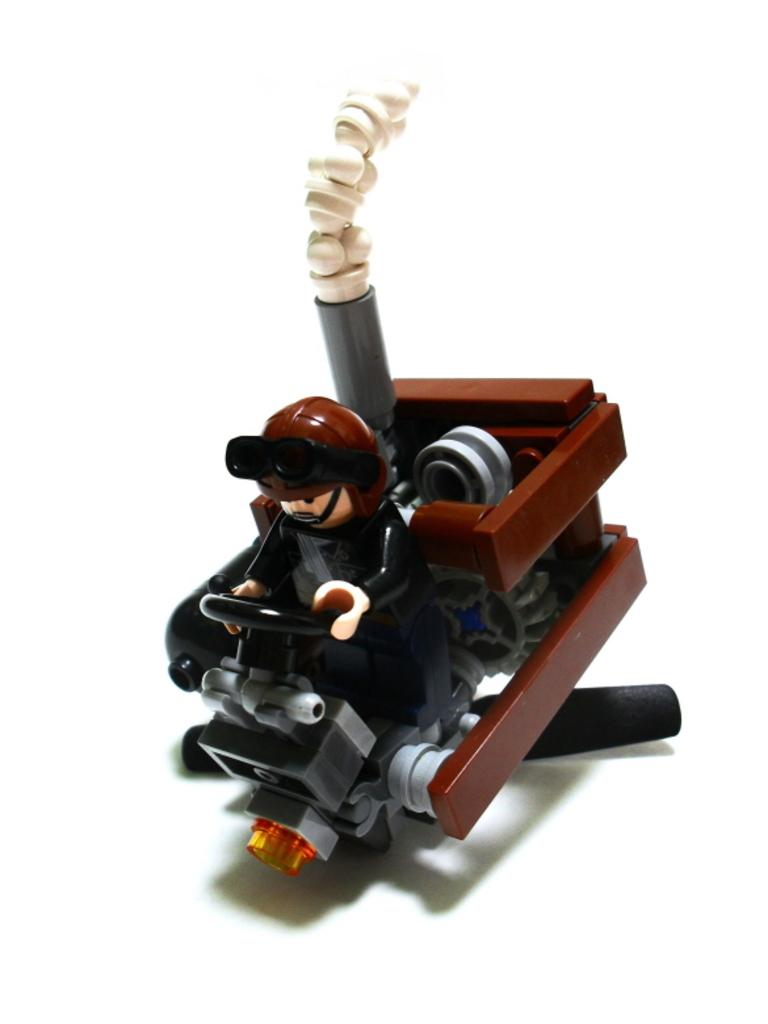What type of toy is present in the image? There is a toy vehicle in the image. Are there any other toys visible in the image? Yes, there is a toy man in the image. What song is the toy vehicle playing in the image? There is no indication in the image that the toy vehicle is playing a song. Can you see any cables connected to the toy man in the image? There is no mention of cables in the image, and therefore no such connection can be observed. 